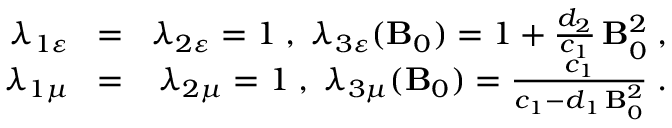<formula> <loc_0><loc_0><loc_500><loc_500>\begin{array} { r l r } { \lambda _ { 1 \varepsilon } \, } & { = } & { \, \lambda _ { 2 \varepsilon } = 1 \, , \, \lambda _ { 3 \varepsilon } ( { B } _ { 0 } ) = 1 + \frac { d _ { 2 } } { c _ { 1 } } \, { B } _ { 0 } ^ { 2 } \, , } \\ { \lambda _ { 1 \mu } \, } & { = } & { \, \lambda _ { 2 \mu } = 1 \, , \, \lambda _ { 3 \mu } ( { B } _ { 0 } ) = \frac { c _ { 1 } } { c _ { 1 } - d _ { 1 } \, { B } _ { 0 } ^ { 2 } } \, . } \end{array}</formula> 